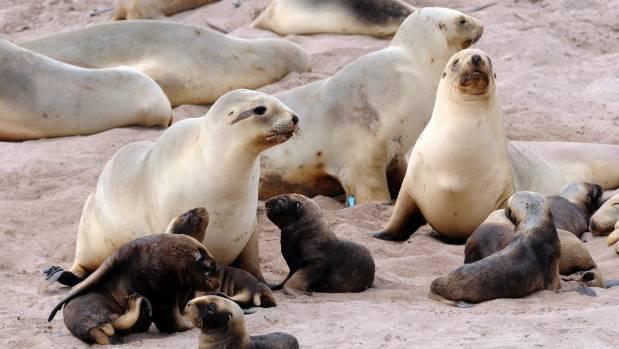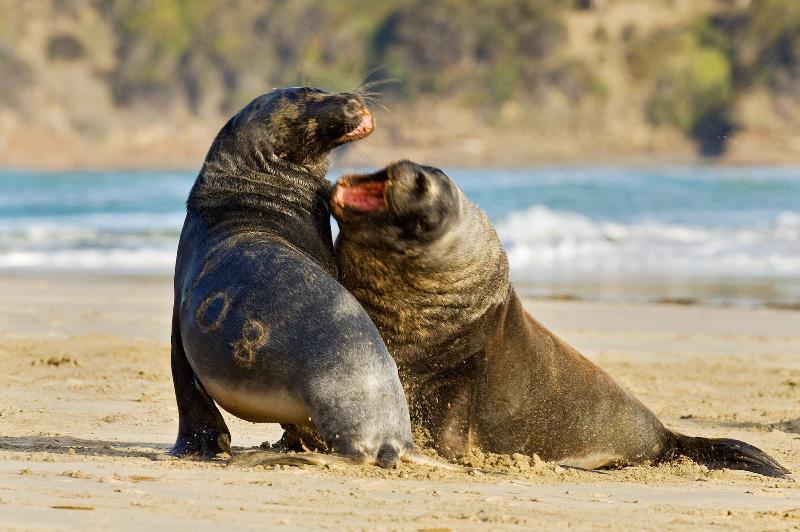The first image is the image on the left, the second image is the image on the right. Considering the images on both sides, is "An image shows at least one small dark seal pup next to a larger paler adult seal." valid? Answer yes or no. Yes. The first image is the image on the left, the second image is the image on the right. Evaluate the accuracy of this statement regarding the images: "There are exactly three animals in the image on the right.". Is it true? Answer yes or no. No. 